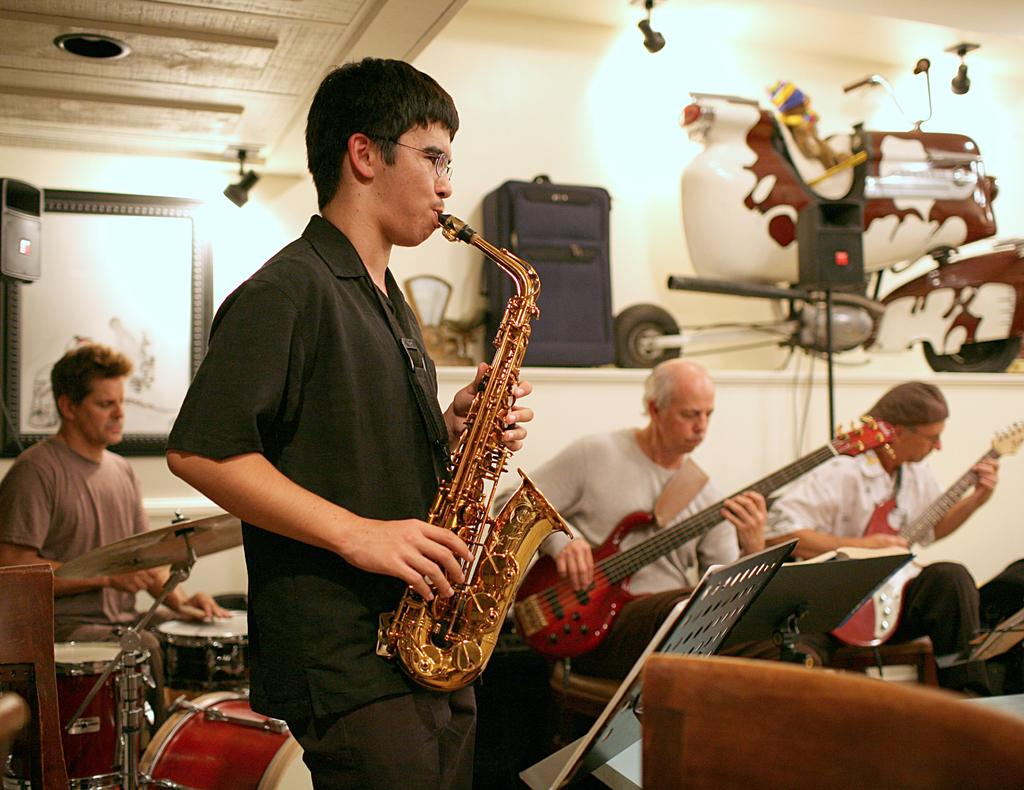What is the man in the image doing? The man is playing a musical instrument in the image. Are there any other people involved in the activity? Yes, there are other persons playing musical instruments in the image. What can be seen in the background of the image? There is a wall visible in the image. What type of pet can be seen sitting on the furniture in the image? There is no pet or furniture present in the image; it features people playing musical instruments with a wall in the background. 